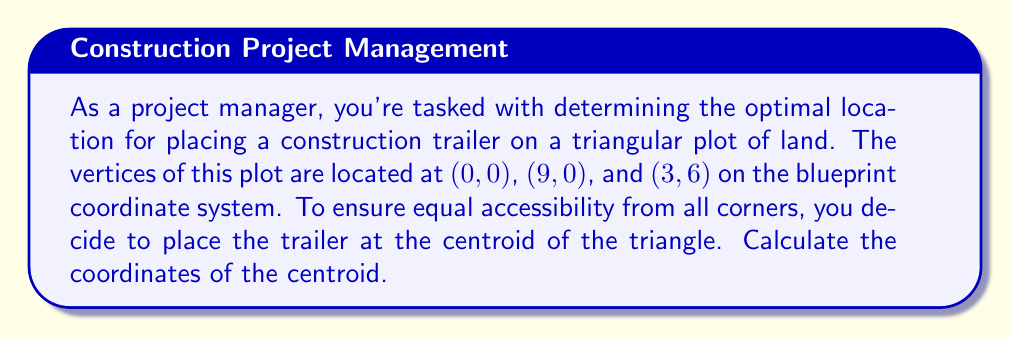Can you answer this question? Let's approach this step-by-step:

1) The centroid of a triangle is located at the intersection of its medians. It can be calculated as the average of the x-coordinates and y-coordinates of the three vertices.

2) The formula for the centroid $(x_c, y_c)$ is:

   $$x_c = \frac{x_1 + x_2 + x_3}{3}$$
   $$y_c = \frac{y_1 + y_2 + y_3}{3}$$

   Where $(x_1, y_1)$, $(x_2, y_2)$, and $(x_3, y_3)$ are the coordinates of the three vertices.

3) We have the following vertices:
   - $A(0, 0)$
   - $B(9, 0)$
   - $C(3, 6)$

4) Let's calculate $x_c$:
   $$x_c = \frac{0 + 9 + 3}{3} = \frac{12}{3} = 4$$

5) Now, let's calculate $y_c$:
   $$y_c = \frac{0 + 0 + 6}{3} = \frac{6}{3} = 2$$

6) Therefore, the centroid is located at (4, 2) on the blueprint coordinate system.

[asy]
unitsize(1cm);
draw((0,0)--(9,0)--(3,6)--cycle);
dot((0,0));
dot((9,0));
dot((3,6));
dot((4,2),red);
label("A(0,0)", (0,0), SW);
label("B(9,0)", (9,0), SE);
label("C(3,6)", (3,6), N);
label("Centroid(4,2)", (4,2), NE);
[/asy]
Answer: (4, 2) 